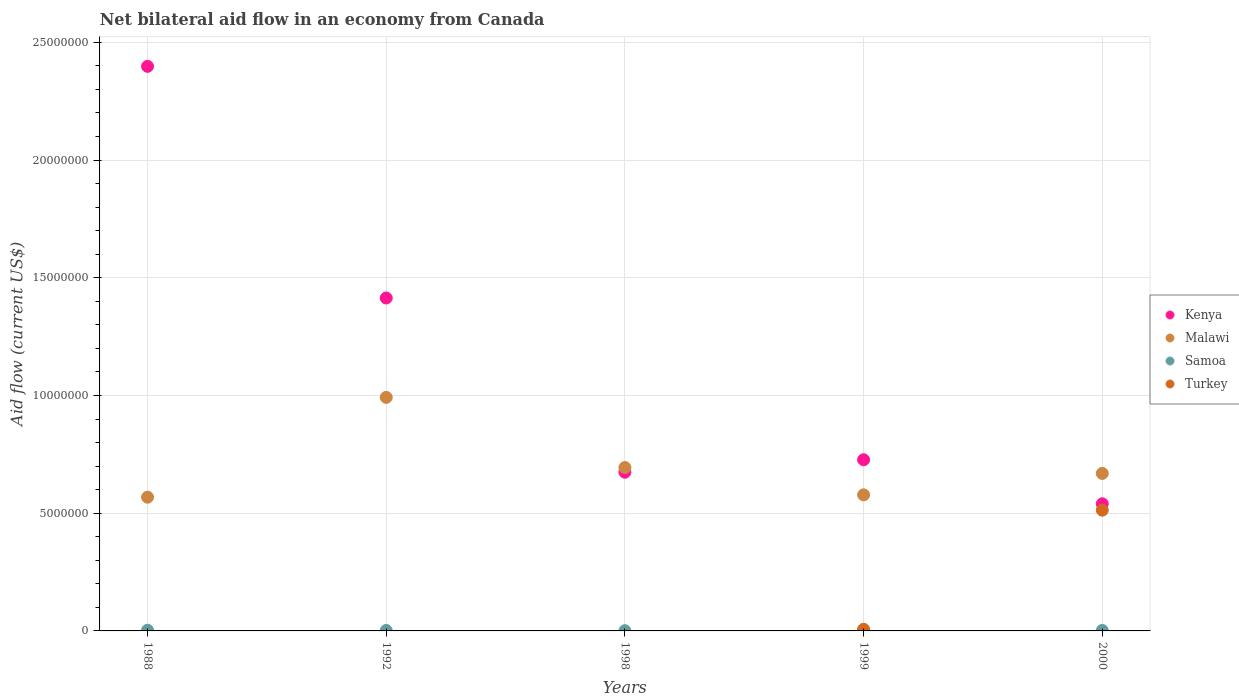What is the net bilateral aid flow in Kenya in 1988?
Make the answer very short. 2.40e+07. Across all years, what is the maximum net bilateral aid flow in Malawi?
Your response must be concise. 9.92e+06. What is the total net bilateral aid flow in Samoa in the graph?
Offer a very short reply. 1.00e+05. What is the average net bilateral aid flow in Kenya per year?
Ensure brevity in your answer.  1.15e+07. In the year 1999, what is the difference between the net bilateral aid flow in Turkey and net bilateral aid flow in Kenya?
Ensure brevity in your answer.  -7.20e+06. In how many years, is the net bilateral aid flow in Samoa greater than 1000000 US$?
Ensure brevity in your answer.  0. What is the ratio of the net bilateral aid flow in Kenya in 1999 to that in 2000?
Offer a very short reply. 1.35. Is the difference between the net bilateral aid flow in Turkey in 1999 and 2000 greater than the difference between the net bilateral aid flow in Kenya in 1999 and 2000?
Offer a terse response. No. What is the difference between the highest and the second highest net bilateral aid flow in Malawi?
Make the answer very short. 2.98e+06. What is the difference between the highest and the lowest net bilateral aid flow in Turkey?
Ensure brevity in your answer.  5.13e+06. Is the sum of the net bilateral aid flow in Malawi in 1992 and 1999 greater than the maximum net bilateral aid flow in Kenya across all years?
Your answer should be very brief. No. Is it the case that in every year, the sum of the net bilateral aid flow in Turkey and net bilateral aid flow in Malawi  is greater than the sum of net bilateral aid flow in Samoa and net bilateral aid flow in Kenya?
Give a very brief answer. No. Is it the case that in every year, the sum of the net bilateral aid flow in Samoa and net bilateral aid flow in Malawi  is greater than the net bilateral aid flow in Turkey?
Keep it short and to the point. Yes. Does the net bilateral aid flow in Kenya monotonically increase over the years?
Make the answer very short. No. Is the net bilateral aid flow in Samoa strictly greater than the net bilateral aid flow in Turkey over the years?
Make the answer very short. No. Is the net bilateral aid flow in Kenya strictly less than the net bilateral aid flow in Turkey over the years?
Your response must be concise. No. How many dotlines are there?
Your answer should be very brief. 4. What is the difference between two consecutive major ticks on the Y-axis?
Offer a terse response. 5.00e+06. Are the values on the major ticks of Y-axis written in scientific E-notation?
Provide a succinct answer. No. Does the graph contain any zero values?
Give a very brief answer. Yes. Does the graph contain grids?
Provide a short and direct response. Yes. How many legend labels are there?
Your answer should be compact. 4. What is the title of the graph?
Offer a terse response. Net bilateral aid flow in an economy from Canada. What is the label or title of the X-axis?
Offer a very short reply. Years. What is the Aid flow (current US$) of Kenya in 1988?
Your answer should be very brief. 2.40e+07. What is the Aid flow (current US$) of Malawi in 1988?
Give a very brief answer. 5.68e+06. What is the Aid flow (current US$) in Samoa in 1988?
Make the answer very short. 3.00e+04. What is the Aid flow (current US$) of Turkey in 1988?
Give a very brief answer. 0. What is the Aid flow (current US$) in Kenya in 1992?
Your answer should be very brief. 1.41e+07. What is the Aid flow (current US$) in Malawi in 1992?
Offer a very short reply. 9.92e+06. What is the Aid flow (current US$) in Samoa in 1992?
Give a very brief answer. 2.00e+04. What is the Aid flow (current US$) of Kenya in 1998?
Ensure brevity in your answer.  6.74e+06. What is the Aid flow (current US$) in Malawi in 1998?
Provide a succinct answer. 6.94e+06. What is the Aid flow (current US$) in Turkey in 1998?
Give a very brief answer. 0. What is the Aid flow (current US$) in Kenya in 1999?
Your response must be concise. 7.27e+06. What is the Aid flow (current US$) of Malawi in 1999?
Keep it short and to the point. 5.78e+06. What is the Aid flow (current US$) in Samoa in 1999?
Your answer should be very brief. 2.00e+04. What is the Aid flow (current US$) of Kenya in 2000?
Your answer should be very brief. 5.40e+06. What is the Aid flow (current US$) in Malawi in 2000?
Offer a very short reply. 6.69e+06. What is the Aid flow (current US$) in Turkey in 2000?
Make the answer very short. 5.13e+06. Across all years, what is the maximum Aid flow (current US$) in Kenya?
Your answer should be compact. 2.40e+07. Across all years, what is the maximum Aid flow (current US$) of Malawi?
Keep it short and to the point. 9.92e+06. Across all years, what is the maximum Aid flow (current US$) in Turkey?
Your response must be concise. 5.13e+06. Across all years, what is the minimum Aid flow (current US$) of Kenya?
Ensure brevity in your answer.  5.40e+06. Across all years, what is the minimum Aid flow (current US$) in Malawi?
Your response must be concise. 5.68e+06. Across all years, what is the minimum Aid flow (current US$) of Samoa?
Offer a terse response. 10000. What is the total Aid flow (current US$) in Kenya in the graph?
Give a very brief answer. 5.75e+07. What is the total Aid flow (current US$) in Malawi in the graph?
Offer a very short reply. 3.50e+07. What is the total Aid flow (current US$) in Turkey in the graph?
Ensure brevity in your answer.  5.20e+06. What is the difference between the Aid flow (current US$) of Kenya in 1988 and that in 1992?
Provide a short and direct response. 9.84e+06. What is the difference between the Aid flow (current US$) in Malawi in 1988 and that in 1992?
Your response must be concise. -4.24e+06. What is the difference between the Aid flow (current US$) of Samoa in 1988 and that in 1992?
Ensure brevity in your answer.  10000. What is the difference between the Aid flow (current US$) in Kenya in 1988 and that in 1998?
Give a very brief answer. 1.72e+07. What is the difference between the Aid flow (current US$) of Malawi in 1988 and that in 1998?
Keep it short and to the point. -1.26e+06. What is the difference between the Aid flow (current US$) in Samoa in 1988 and that in 1998?
Offer a very short reply. 2.00e+04. What is the difference between the Aid flow (current US$) of Kenya in 1988 and that in 1999?
Offer a very short reply. 1.67e+07. What is the difference between the Aid flow (current US$) of Samoa in 1988 and that in 1999?
Offer a very short reply. 10000. What is the difference between the Aid flow (current US$) of Kenya in 1988 and that in 2000?
Provide a short and direct response. 1.86e+07. What is the difference between the Aid flow (current US$) in Malawi in 1988 and that in 2000?
Ensure brevity in your answer.  -1.01e+06. What is the difference between the Aid flow (current US$) in Samoa in 1988 and that in 2000?
Keep it short and to the point. 10000. What is the difference between the Aid flow (current US$) of Kenya in 1992 and that in 1998?
Your response must be concise. 7.40e+06. What is the difference between the Aid flow (current US$) of Malawi in 1992 and that in 1998?
Your response must be concise. 2.98e+06. What is the difference between the Aid flow (current US$) in Kenya in 1992 and that in 1999?
Your answer should be very brief. 6.87e+06. What is the difference between the Aid flow (current US$) in Malawi in 1992 and that in 1999?
Offer a very short reply. 4.14e+06. What is the difference between the Aid flow (current US$) in Samoa in 1992 and that in 1999?
Your answer should be very brief. 0. What is the difference between the Aid flow (current US$) of Kenya in 1992 and that in 2000?
Ensure brevity in your answer.  8.74e+06. What is the difference between the Aid flow (current US$) of Malawi in 1992 and that in 2000?
Your response must be concise. 3.23e+06. What is the difference between the Aid flow (current US$) of Kenya in 1998 and that in 1999?
Your answer should be very brief. -5.30e+05. What is the difference between the Aid flow (current US$) of Malawi in 1998 and that in 1999?
Your answer should be very brief. 1.16e+06. What is the difference between the Aid flow (current US$) in Samoa in 1998 and that in 1999?
Make the answer very short. -10000. What is the difference between the Aid flow (current US$) of Kenya in 1998 and that in 2000?
Give a very brief answer. 1.34e+06. What is the difference between the Aid flow (current US$) in Malawi in 1998 and that in 2000?
Give a very brief answer. 2.50e+05. What is the difference between the Aid flow (current US$) in Samoa in 1998 and that in 2000?
Offer a terse response. -10000. What is the difference between the Aid flow (current US$) of Kenya in 1999 and that in 2000?
Give a very brief answer. 1.87e+06. What is the difference between the Aid flow (current US$) of Malawi in 1999 and that in 2000?
Ensure brevity in your answer.  -9.10e+05. What is the difference between the Aid flow (current US$) in Turkey in 1999 and that in 2000?
Your answer should be compact. -5.06e+06. What is the difference between the Aid flow (current US$) in Kenya in 1988 and the Aid flow (current US$) in Malawi in 1992?
Provide a succinct answer. 1.41e+07. What is the difference between the Aid flow (current US$) in Kenya in 1988 and the Aid flow (current US$) in Samoa in 1992?
Provide a succinct answer. 2.40e+07. What is the difference between the Aid flow (current US$) in Malawi in 1988 and the Aid flow (current US$) in Samoa in 1992?
Your response must be concise. 5.66e+06. What is the difference between the Aid flow (current US$) in Kenya in 1988 and the Aid flow (current US$) in Malawi in 1998?
Your answer should be very brief. 1.70e+07. What is the difference between the Aid flow (current US$) of Kenya in 1988 and the Aid flow (current US$) of Samoa in 1998?
Offer a terse response. 2.40e+07. What is the difference between the Aid flow (current US$) of Malawi in 1988 and the Aid flow (current US$) of Samoa in 1998?
Give a very brief answer. 5.67e+06. What is the difference between the Aid flow (current US$) of Kenya in 1988 and the Aid flow (current US$) of Malawi in 1999?
Provide a short and direct response. 1.82e+07. What is the difference between the Aid flow (current US$) in Kenya in 1988 and the Aid flow (current US$) in Samoa in 1999?
Offer a very short reply. 2.40e+07. What is the difference between the Aid flow (current US$) in Kenya in 1988 and the Aid flow (current US$) in Turkey in 1999?
Ensure brevity in your answer.  2.39e+07. What is the difference between the Aid flow (current US$) of Malawi in 1988 and the Aid flow (current US$) of Samoa in 1999?
Make the answer very short. 5.66e+06. What is the difference between the Aid flow (current US$) of Malawi in 1988 and the Aid flow (current US$) of Turkey in 1999?
Your response must be concise. 5.61e+06. What is the difference between the Aid flow (current US$) in Samoa in 1988 and the Aid flow (current US$) in Turkey in 1999?
Ensure brevity in your answer.  -4.00e+04. What is the difference between the Aid flow (current US$) of Kenya in 1988 and the Aid flow (current US$) of Malawi in 2000?
Provide a short and direct response. 1.73e+07. What is the difference between the Aid flow (current US$) in Kenya in 1988 and the Aid flow (current US$) in Samoa in 2000?
Your answer should be compact. 2.40e+07. What is the difference between the Aid flow (current US$) of Kenya in 1988 and the Aid flow (current US$) of Turkey in 2000?
Your answer should be very brief. 1.88e+07. What is the difference between the Aid flow (current US$) of Malawi in 1988 and the Aid flow (current US$) of Samoa in 2000?
Your response must be concise. 5.66e+06. What is the difference between the Aid flow (current US$) in Samoa in 1988 and the Aid flow (current US$) in Turkey in 2000?
Your answer should be very brief. -5.10e+06. What is the difference between the Aid flow (current US$) in Kenya in 1992 and the Aid flow (current US$) in Malawi in 1998?
Your response must be concise. 7.20e+06. What is the difference between the Aid flow (current US$) in Kenya in 1992 and the Aid flow (current US$) in Samoa in 1998?
Give a very brief answer. 1.41e+07. What is the difference between the Aid flow (current US$) in Malawi in 1992 and the Aid flow (current US$) in Samoa in 1998?
Ensure brevity in your answer.  9.91e+06. What is the difference between the Aid flow (current US$) in Kenya in 1992 and the Aid flow (current US$) in Malawi in 1999?
Provide a succinct answer. 8.36e+06. What is the difference between the Aid flow (current US$) of Kenya in 1992 and the Aid flow (current US$) of Samoa in 1999?
Provide a succinct answer. 1.41e+07. What is the difference between the Aid flow (current US$) in Kenya in 1992 and the Aid flow (current US$) in Turkey in 1999?
Make the answer very short. 1.41e+07. What is the difference between the Aid flow (current US$) in Malawi in 1992 and the Aid flow (current US$) in Samoa in 1999?
Give a very brief answer. 9.90e+06. What is the difference between the Aid flow (current US$) of Malawi in 1992 and the Aid flow (current US$) of Turkey in 1999?
Offer a very short reply. 9.85e+06. What is the difference between the Aid flow (current US$) of Kenya in 1992 and the Aid flow (current US$) of Malawi in 2000?
Provide a succinct answer. 7.45e+06. What is the difference between the Aid flow (current US$) in Kenya in 1992 and the Aid flow (current US$) in Samoa in 2000?
Provide a short and direct response. 1.41e+07. What is the difference between the Aid flow (current US$) of Kenya in 1992 and the Aid flow (current US$) of Turkey in 2000?
Your answer should be compact. 9.01e+06. What is the difference between the Aid flow (current US$) in Malawi in 1992 and the Aid flow (current US$) in Samoa in 2000?
Give a very brief answer. 9.90e+06. What is the difference between the Aid flow (current US$) in Malawi in 1992 and the Aid flow (current US$) in Turkey in 2000?
Offer a very short reply. 4.79e+06. What is the difference between the Aid flow (current US$) in Samoa in 1992 and the Aid flow (current US$) in Turkey in 2000?
Your answer should be compact. -5.11e+06. What is the difference between the Aid flow (current US$) in Kenya in 1998 and the Aid flow (current US$) in Malawi in 1999?
Your answer should be compact. 9.60e+05. What is the difference between the Aid flow (current US$) in Kenya in 1998 and the Aid flow (current US$) in Samoa in 1999?
Your response must be concise. 6.72e+06. What is the difference between the Aid flow (current US$) of Kenya in 1998 and the Aid flow (current US$) of Turkey in 1999?
Keep it short and to the point. 6.67e+06. What is the difference between the Aid flow (current US$) in Malawi in 1998 and the Aid flow (current US$) in Samoa in 1999?
Provide a short and direct response. 6.92e+06. What is the difference between the Aid flow (current US$) of Malawi in 1998 and the Aid flow (current US$) of Turkey in 1999?
Provide a succinct answer. 6.87e+06. What is the difference between the Aid flow (current US$) of Kenya in 1998 and the Aid flow (current US$) of Samoa in 2000?
Give a very brief answer. 6.72e+06. What is the difference between the Aid flow (current US$) in Kenya in 1998 and the Aid flow (current US$) in Turkey in 2000?
Your answer should be compact. 1.61e+06. What is the difference between the Aid flow (current US$) in Malawi in 1998 and the Aid flow (current US$) in Samoa in 2000?
Provide a succinct answer. 6.92e+06. What is the difference between the Aid flow (current US$) in Malawi in 1998 and the Aid flow (current US$) in Turkey in 2000?
Give a very brief answer. 1.81e+06. What is the difference between the Aid flow (current US$) of Samoa in 1998 and the Aid flow (current US$) of Turkey in 2000?
Provide a succinct answer. -5.12e+06. What is the difference between the Aid flow (current US$) of Kenya in 1999 and the Aid flow (current US$) of Malawi in 2000?
Keep it short and to the point. 5.80e+05. What is the difference between the Aid flow (current US$) of Kenya in 1999 and the Aid flow (current US$) of Samoa in 2000?
Provide a succinct answer. 7.25e+06. What is the difference between the Aid flow (current US$) of Kenya in 1999 and the Aid flow (current US$) of Turkey in 2000?
Ensure brevity in your answer.  2.14e+06. What is the difference between the Aid flow (current US$) of Malawi in 1999 and the Aid flow (current US$) of Samoa in 2000?
Your answer should be very brief. 5.76e+06. What is the difference between the Aid flow (current US$) of Malawi in 1999 and the Aid flow (current US$) of Turkey in 2000?
Give a very brief answer. 6.50e+05. What is the difference between the Aid flow (current US$) of Samoa in 1999 and the Aid flow (current US$) of Turkey in 2000?
Your answer should be very brief. -5.11e+06. What is the average Aid flow (current US$) in Kenya per year?
Give a very brief answer. 1.15e+07. What is the average Aid flow (current US$) in Malawi per year?
Offer a terse response. 7.00e+06. What is the average Aid flow (current US$) in Turkey per year?
Provide a succinct answer. 1.04e+06. In the year 1988, what is the difference between the Aid flow (current US$) in Kenya and Aid flow (current US$) in Malawi?
Your answer should be compact. 1.83e+07. In the year 1988, what is the difference between the Aid flow (current US$) in Kenya and Aid flow (current US$) in Samoa?
Offer a terse response. 2.40e+07. In the year 1988, what is the difference between the Aid flow (current US$) in Malawi and Aid flow (current US$) in Samoa?
Make the answer very short. 5.65e+06. In the year 1992, what is the difference between the Aid flow (current US$) in Kenya and Aid flow (current US$) in Malawi?
Your response must be concise. 4.22e+06. In the year 1992, what is the difference between the Aid flow (current US$) in Kenya and Aid flow (current US$) in Samoa?
Provide a succinct answer. 1.41e+07. In the year 1992, what is the difference between the Aid flow (current US$) in Malawi and Aid flow (current US$) in Samoa?
Provide a succinct answer. 9.90e+06. In the year 1998, what is the difference between the Aid flow (current US$) of Kenya and Aid flow (current US$) of Samoa?
Ensure brevity in your answer.  6.73e+06. In the year 1998, what is the difference between the Aid flow (current US$) in Malawi and Aid flow (current US$) in Samoa?
Offer a terse response. 6.93e+06. In the year 1999, what is the difference between the Aid flow (current US$) of Kenya and Aid flow (current US$) of Malawi?
Your answer should be very brief. 1.49e+06. In the year 1999, what is the difference between the Aid flow (current US$) of Kenya and Aid flow (current US$) of Samoa?
Offer a very short reply. 7.25e+06. In the year 1999, what is the difference between the Aid flow (current US$) in Kenya and Aid flow (current US$) in Turkey?
Ensure brevity in your answer.  7.20e+06. In the year 1999, what is the difference between the Aid flow (current US$) of Malawi and Aid flow (current US$) of Samoa?
Ensure brevity in your answer.  5.76e+06. In the year 1999, what is the difference between the Aid flow (current US$) of Malawi and Aid flow (current US$) of Turkey?
Provide a succinct answer. 5.71e+06. In the year 2000, what is the difference between the Aid flow (current US$) in Kenya and Aid flow (current US$) in Malawi?
Give a very brief answer. -1.29e+06. In the year 2000, what is the difference between the Aid flow (current US$) in Kenya and Aid flow (current US$) in Samoa?
Your answer should be very brief. 5.38e+06. In the year 2000, what is the difference between the Aid flow (current US$) in Kenya and Aid flow (current US$) in Turkey?
Your answer should be very brief. 2.70e+05. In the year 2000, what is the difference between the Aid flow (current US$) of Malawi and Aid flow (current US$) of Samoa?
Ensure brevity in your answer.  6.67e+06. In the year 2000, what is the difference between the Aid flow (current US$) in Malawi and Aid flow (current US$) in Turkey?
Give a very brief answer. 1.56e+06. In the year 2000, what is the difference between the Aid flow (current US$) in Samoa and Aid flow (current US$) in Turkey?
Give a very brief answer. -5.11e+06. What is the ratio of the Aid flow (current US$) of Kenya in 1988 to that in 1992?
Your answer should be very brief. 1.7. What is the ratio of the Aid flow (current US$) of Malawi in 1988 to that in 1992?
Offer a very short reply. 0.57. What is the ratio of the Aid flow (current US$) of Samoa in 1988 to that in 1992?
Offer a terse response. 1.5. What is the ratio of the Aid flow (current US$) in Kenya in 1988 to that in 1998?
Provide a short and direct response. 3.56. What is the ratio of the Aid flow (current US$) of Malawi in 1988 to that in 1998?
Keep it short and to the point. 0.82. What is the ratio of the Aid flow (current US$) in Samoa in 1988 to that in 1998?
Offer a very short reply. 3. What is the ratio of the Aid flow (current US$) in Kenya in 1988 to that in 1999?
Offer a very short reply. 3.3. What is the ratio of the Aid flow (current US$) in Malawi in 1988 to that in 1999?
Provide a short and direct response. 0.98. What is the ratio of the Aid flow (current US$) in Kenya in 1988 to that in 2000?
Your answer should be compact. 4.44. What is the ratio of the Aid flow (current US$) of Malawi in 1988 to that in 2000?
Provide a short and direct response. 0.85. What is the ratio of the Aid flow (current US$) in Kenya in 1992 to that in 1998?
Ensure brevity in your answer.  2.1. What is the ratio of the Aid flow (current US$) in Malawi in 1992 to that in 1998?
Your answer should be very brief. 1.43. What is the ratio of the Aid flow (current US$) of Kenya in 1992 to that in 1999?
Provide a succinct answer. 1.95. What is the ratio of the Aid flow (current US$) of Malawi in 1992 to that in 1999?
Your answer should be compact. 1.72. What is the ratio of the Aid flow (current US$) of Kenya in 1992 to that in 2000?
Keep it short and to the point. 2.62. What is the ratio of the Aid flow (current US$) in Malawi in 1992 to that in 2000?
Offer a terse response. 1.48. What is the ratio of the Aid flow (current US$) in Samoa in 1992 to that in 2000?
Keep it short and to the point. 1. What is the ratio of the Aid flow (current US$) in Kenya in 1998 to that in 1999?
Give a very brief answer. 0.93. What is the ratio of the Aid flow (current US$) of Malawi in 1998 to that in 1999?
Your answer should be compact. 1.2. What is the ratio of the Aid flow (current US$) of Samoa in 1998 to that in 1999?
Keep it short and to the point. 0.5. What is the ratio of the Aid flow (current US$) in Kenya in 1998 to that in 2000?
Your answer should be compact. 1.25. What is the ratio of the Aid flow (current US$) of Malawi in 1998 to that in 2000?
Offer a very short reply. 1.04. What is the ratio of the Aid flow (current US$) in Kenya in 1999 to that in 2000?
Make the answer very short. 1.35. What is the ratio of the Aid flow (current US$) of Malawi in 1999 to that in 2000?
Your response must be concise. 0.86. What is the ratio of the Aid flow (current US$) of Samoa in 1999 to that in 2000?
Your answer should be compact. 1. What is the ratio of the Aid flow (current US$) in Turkey in 1999 to that in 2000?
Offer a terse response. 0.01. What is the difference between the highest and the second highest Aid flow (current US$) of Kenya?
Ensure brevity in your answer.  9.84e+06. What is the difference between the highest and the second highest Aid flow (current US$) of Malawi?
Your answer should be compact. 2.98e+06. What is the difference between the highest and the lowest Aid flow (current US$) in Kenya?
Your answer should be very brief. 1.86e+07. What is the difference between the highest and the lowest Aid flow (current US$) in Malawi?
Your answer should be compact. 4.24e+06. What is the difference between the highest and the lowest Aid flow (current US$) in Samoa?
Provide a short and direct response. 2.00e+04. What is the difference between the highest and the lowest Aid flow (current US$) in Turkey?
Keep it short and to the point. 5.13e+06. 